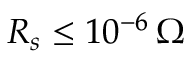<formula> <loc_0><loc_0><loc_500><loc_500>R _ { s } \leq 1 0 ^ { - 6 } \, \Omega</formula> 